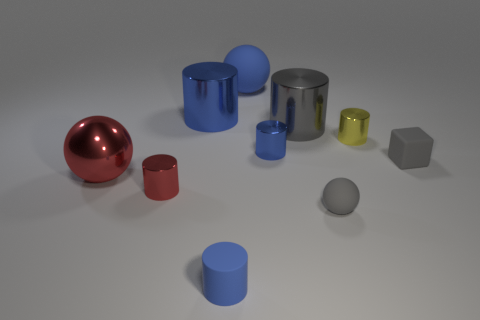Subtract all matte spheres. How many spheres are left? 1 Subtract 1 balls. How many balls are left? 2 Subtract all green cubes. How many blue cylinders are left? 3 Subtract all gray cylinders. How many cylinders are left? 5 Subtract all blocks. How many objects are left? 9 Subtract all brown cylinders. Subtract all purple cubes. How many cylinders are left? 6 Subtract all cylinders. Subtract all large green matte blocks. How many objects are left? 4 Add 2 small yellow shiny things. How many small yellow shiny things are left? 3 Add 1 big red shiny objects. How many big red shiny objects exist? 2 Subtract 0 purple cylinders. How many objects are left? 10 